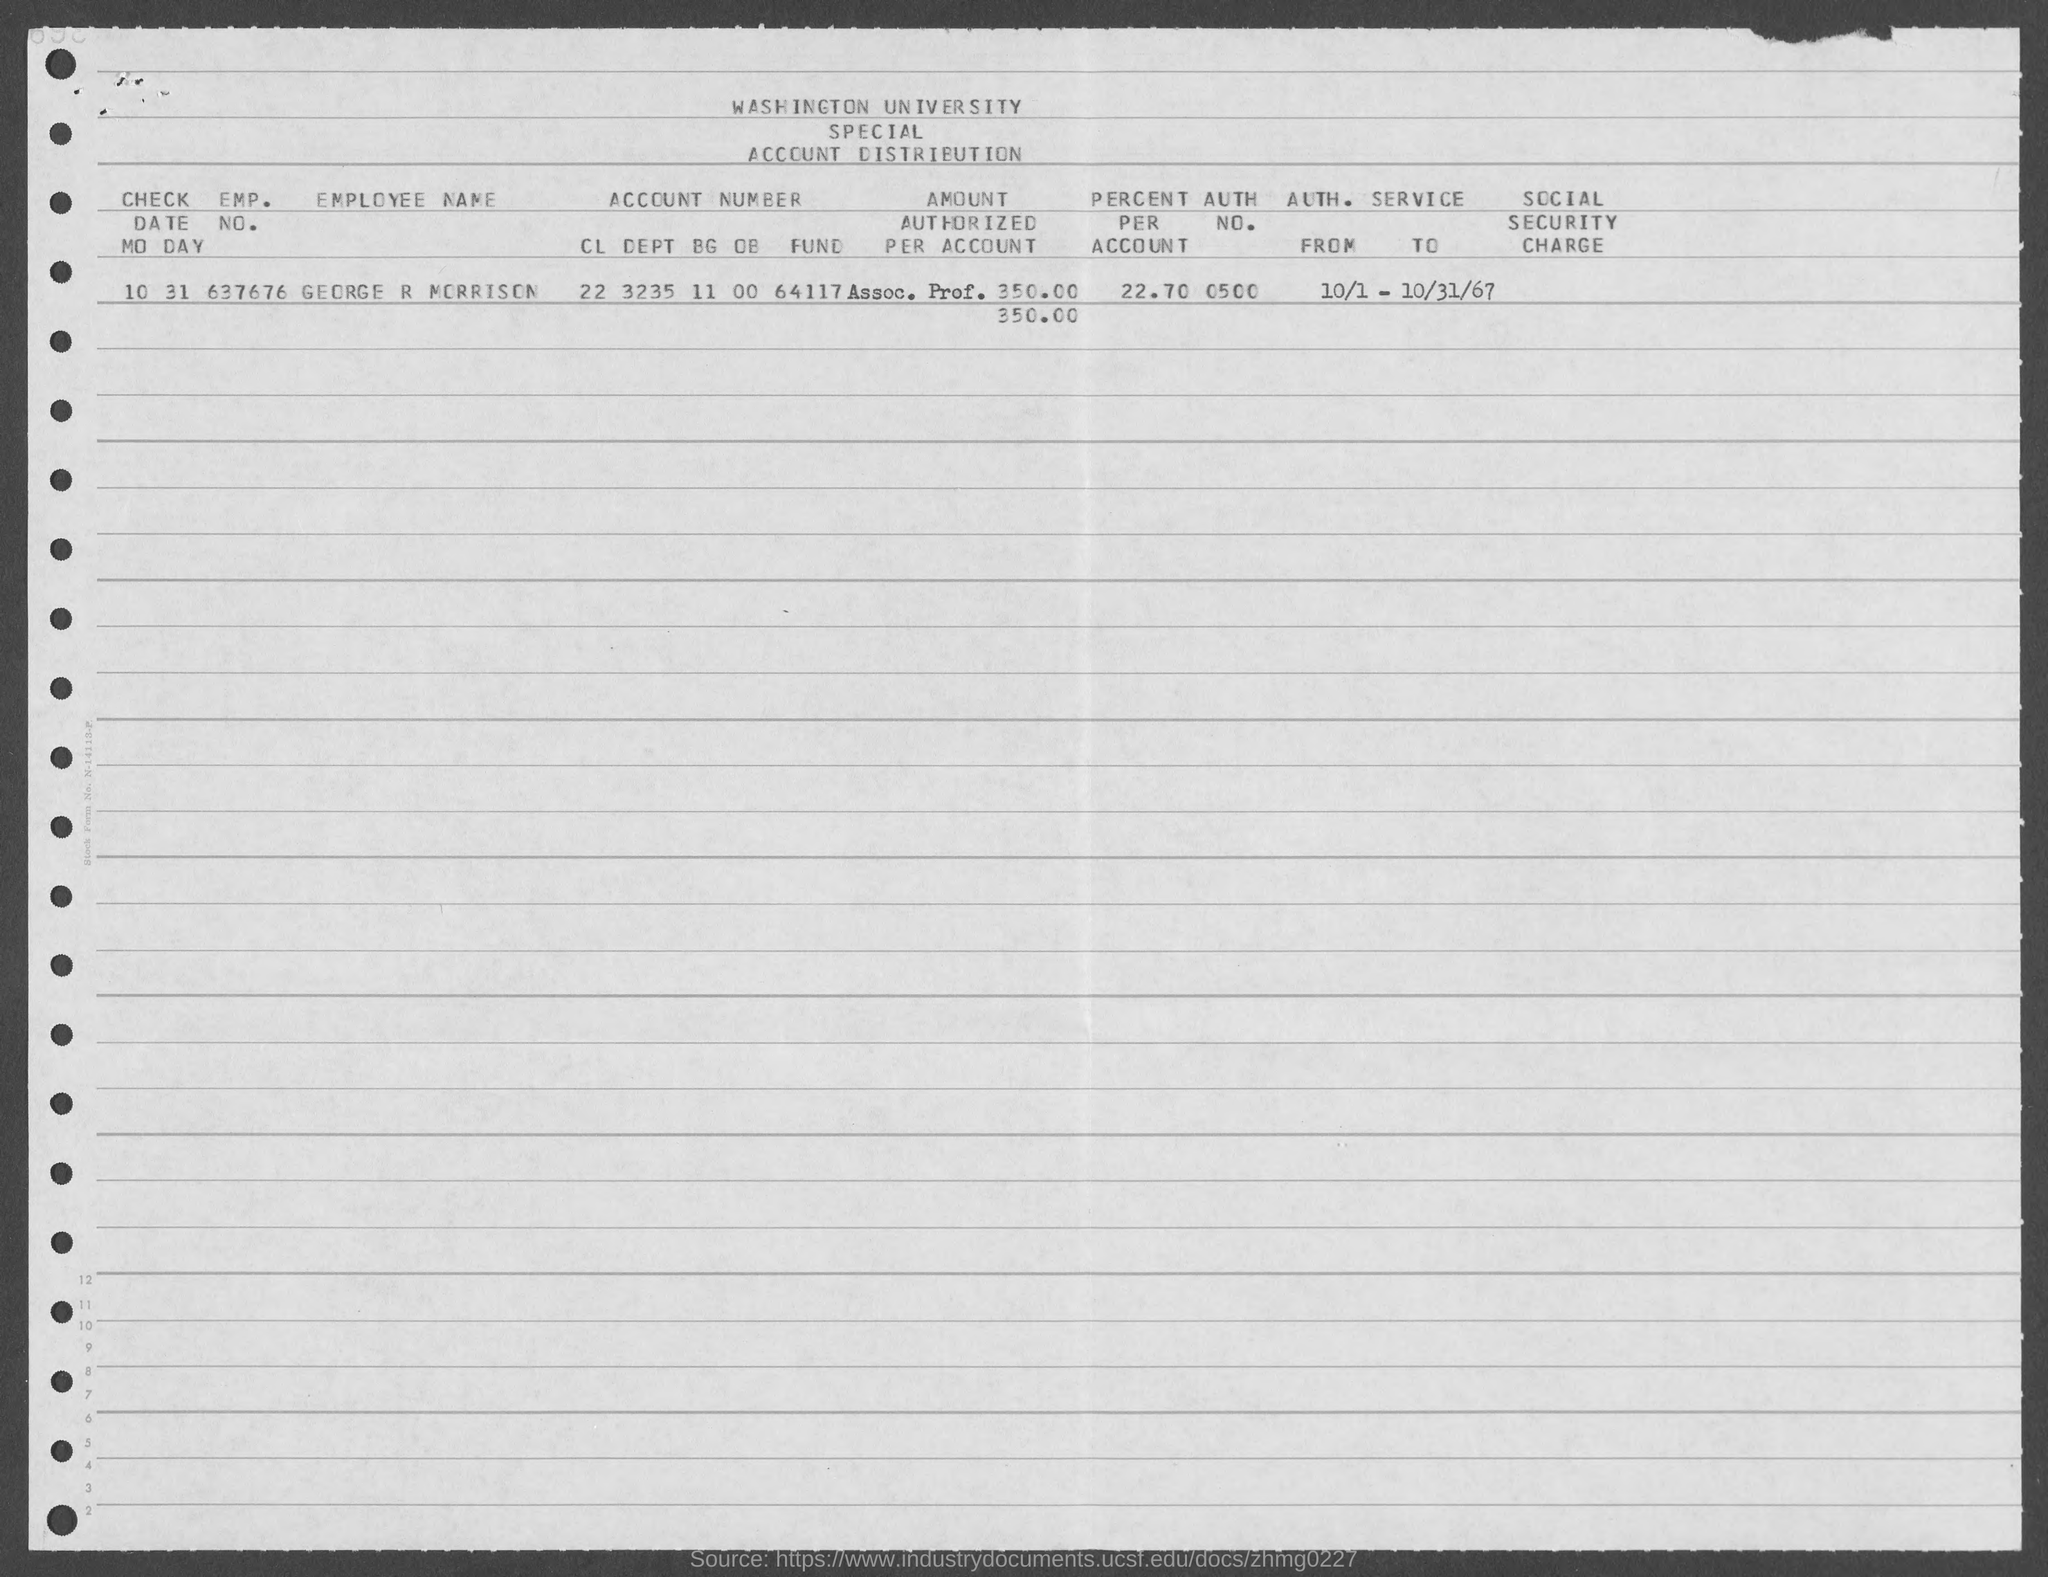What is the emp. no. of george r morrison ?
Give a very brief answer. 637676. What is the auth. no. of george r morrison ?
Your answer should be very brief. 0500. What is the percent per account of george r morrison ?
Your answer should be very brief. $22.70. What is the check date mo day?
Offer a terse response. 10 31. 